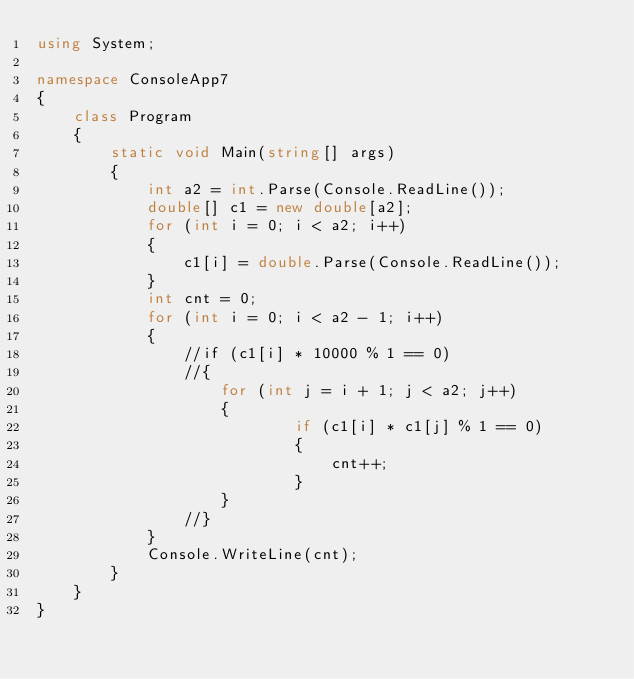<code> <loc_0><loc_0><loc_500><loc_500><_C#_>using System;

namespace ConsoleApp7
{
    class Program
    {
        static void Main(string[] args)
        {
            int a2 = int.Parse(Console.ReadLine());
            double[] c1 = new double[a2];
            for (int i = 0; i < a2; i++)
            {
                c1[i] = double.Parse(Console.ReadLine());
            }
            int cnt = 0;
            for (int i = 0; i < a2 - 1; i++)
            {
                //if (c1[i] * 10000 % 1 == 0)
                //{
                    for (int j = i + 1; j < a2; j++)
                    {
                            if (c1[i] * c1[j] % 1 == 0)
                            {
                                cnt++;
                            }
                    }
                //}
            }
            Console.WriteLine(cnt);
        }
    }
}
</code> 